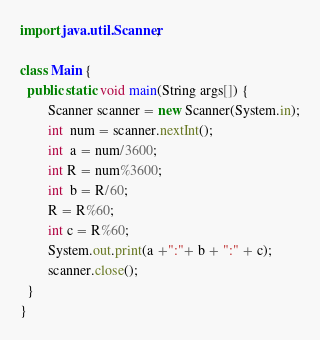<code> <loc_0><loc_0><loc_500><loc_500><_Java_>import java.util.Scanner;

class Main {
  public static void main(String args[]) {
	  	Scanner scanner = new Scanner(System.in);
	  	int  num = scanner.nextInt();
	  	int  a = num/3600;
	  	int R = num%3600;
	  	int  b = R/60;
	  	R = R%60;
	  	int c = R%60;
        System.out.print(a +":"+ b + ":" + c);
        scanner.close();
  }
}
</code> 